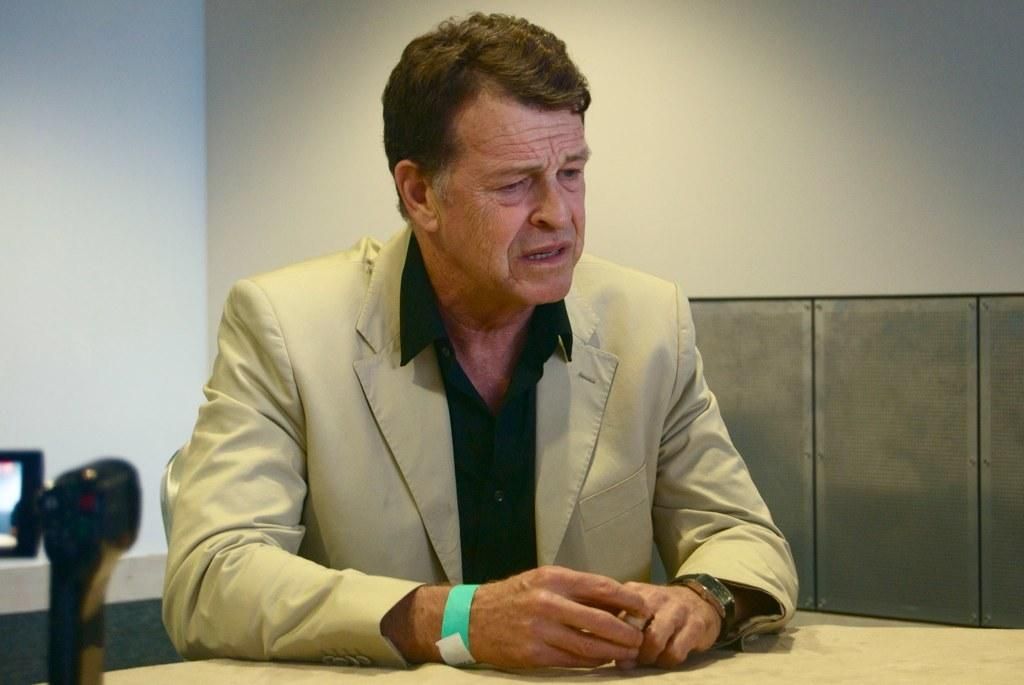Who is the main subject in the picture? There is a man in the picture. What is the man doing in the image? The man is sitting in the image. Where is the man located in relation to the table? The man is in front of a table in the image. What is the man doing while sitting? The man is speaking in the image. What color is the wall behind the man? The wall behind the man is white. What type of lunch is the man eating in the image? There is no lunch present in the image; the man is sitting and speaking in front of a table. 